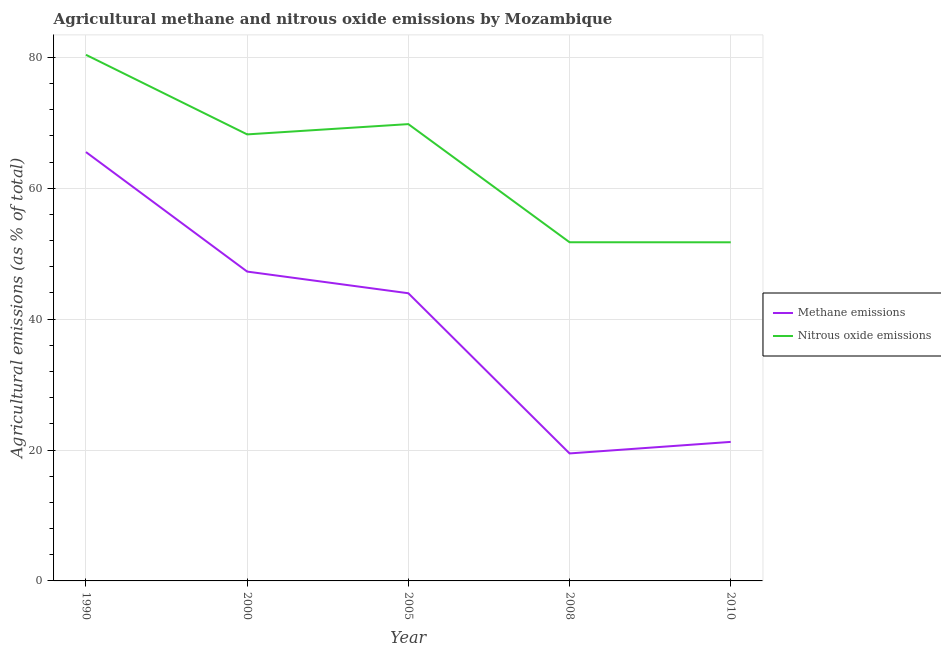How many different coloured lines are there?
Keep it short and to the point. 2. Does the line corresponding to amount of methane emissions intersect with the line corresponding to amount of nitrous oxide emissions?
Offer a very short reply. No. Is the number of lines equal to the number of legend labels?
Your response must be concise. Yes. What is the amount of nitrous oxide emissions in 2008?
Give a very brief answer. 51.75. Across all years, what is the maximum amount of methane emissions?
Ensure brevity in your answer.  65.53. Across all years, what is the minimum amount of nitrous oxide emissions?
Keep it short and to the point. 51.74. What is the total amount of nitrous oxide emissions in the graph?
Your answer should be compact. 321.92. What is the difference between the amount of nitrous oxide emissions in 2008 and that in 2010?
Offer a terse response. 0.01. What is the difference between the amount of nitrous oxide emissions in 2005 and the amount of methane emissions in 1990?
Ensure brevity in your answer.  4.27. What is the average amount of nitrous oxide emissions per year?
Provide a succinct answer. 64.38. In the year 2008, what is the difference between the amount of methane emissions and amount of nitrous oxide emissions?
Offer a very short reply. -32.27. In how many years, is the amount of nitrous oxide emissions greater than 32 %?
Your response must be concise. 5. What is the ratio of the amount of methane emissions in 2008 to that in 2010?
Keep it short and to the point. 0.92. What is the difference between the highest and the second highest amount of methane emissions?
Provide a short and direct response. 18.26. What is the difference between the highest and the lowest amount of methane emissions?
Ensure brevity in your answer.  46.05. How many lines are there?
Your answer should be compact. 2. How many years are there in the graph?
Your answer should be very brief. 5. What is the difference between two consecutive major ticks on the Y-axis?
Offer a very short reply. 20. How many legend labels are there?
Your answer should be very brief. 2. How are the legend labels stacked?
Provide a short and direct response. Vertical. What is the title of the graph?
Offer a terse response. Agricultural methane and nitrous oxide emissions by Mozambique. Does "Urban Population" appear as one of the legend labels in the graph?
Offer a very short reply. No. What is the label or title of the X-axis?
Offer a very short reply. Year. What is the label or title of the Y-axis?
Your response must be concise. Agricultural emissions (as % of total). What is the Agricultural emissions (as % of total) in Methane emissions in 1990?
Your answer should be compact. 65.53. What is the Agricultural emissions (as % of total) in Nitrous oxide emissions in 1990?
Your answer should be compact. 80.39. What is the Agricultural emissions (as % of total) in Methane emissions in 2000?
Your answer should be compact. 47.27. What is the Agricultural emissions (as % of total) in Nitrous oxide emissions in 2000?
Your answer should be compact. 68.23. What is the Agricultural emissions (as % of total) in Methane emissions in 2005?
Your answer should be compact. 43.96. What is the Agricultural emissions (as % of total) of Nitrous oxide emissions in 2005?
Keep it short and to the point. 69.8. What is the Agricultural emissions (as % of total) in Methane emissions in 2008?
Provide a succinct answer. 19.48. What is the Agricultural emissions (as % of total) of Nitrous oxide emissions in 2008?
Provide a short and direct response. 51.75. What is the Agricultural emissions (as % of total) in Methane emissions in 2010?
Offer a terse response. 21.24. What is the Agricultural emissions (as % of total) of Nitrous oxide emissions in 2010?
Offer a very short reply. 51.74. Across all years, what is the maximum Agricultural emissions (as % of total) in Methane emissions?
Offer a terse response. 65.53. Across all years, what is the maximum Agricultural emissions (as % of total) in Nitrous oxide emissions?
Your answer should be very brief. 80.39. Across all years, what is the minimum Agricultural emissions (as % of total) of Methane emissions?
Make the answer very short. 19.48. Across all years, what is the minimum Agricultural emissions (as % of total) in Nitrous oxide emissions?
Make the answer very short. 51.74. What is the total Agricultural emissions (as % of total) of Methane emissions in the graph?
Provide a succinct answer. 197.48. What is the total Agricultural emissions (as % of total) in Nitrous oxide emissions in the graph?
Offer a terse response. 321.92. What is the difference between the Agricultural emissions (as % of total) in Methane emissions in 1990 and that in 2000?
Offer a very short reply. 18.26. What is the difference between the Agricultural emissions (as % of total) in Nitrous oxide emissions in 1990 and that in 2000?
Your response must be concise. 12.16. What is the difference between the Agricultural emissions (as % of total) of Methane emissions in 1990 and that in 2005?
Your answer should be compact. 21.57. What is the difference between the Agricultural emissions (as % of total) in Nitrous oxide emissions in 1990 and that in 2005?
Your answer should be very brief. 10.59. What is the difference between the Agricultural emissions (as % of total) in Methane emissions in 1990 and that in 2008?
Your answer should be very brief. 46.05. What is the difference between the Agricultural emissions (as % of total) in Nitrous oxide emissions in 1990 and that in 2008?
Provide a succinct answer. 28.64. What is the difference between the Agricultural emissions (as % of total) in Methane emissions in 1990 and that in 2010?
Your answer should be very brief. 44.29. What is the difference between the Agricultural emissions (as % of total) of Nitrous oxide emissions in 1990 and that in 2010?
Your response must be concise. 28.65. What is the difference between the Agricultural emissions (as % of total) of Methane emissions in 2000 and that in 2005?
Offer a terse response. 3.31. What is the difference between the Agricultural emissions (as % of total) in Nitrous oxide emissions in 2000 and that in 2005?
Offer a very short reply. -1.57. What is the difference between the Agricultural emissions (as % of total) of Methane emissions in 2000 and that in 2008?
Give a very brief answer. 27.79. What is the difference between the Agricultural emissions (as % of total) in Nitrous oxide emissions in 2000 and that in 2008?
Make the answer very short. 16.48. What is the difference between the Agricultural emissions (as % of total) in Methane emissions in 2000 and that in 2010?
Ensure brevity in your answer.  26.02. What is the difference between the Agricultural emissions (as % of total) in Nitrous oxide emissions in 2000 and that in 2010?
Offer a terse response. 16.49. What is the difference between the Agricultural emissions (as % of total) of Methane emissions in 2005 and that in 2008?
Offer a very short reply. 24.48. What is the difference between the Agricultural emissions (as % of total) of Nitrous oxide emissions in 2005 and that in 2008?
Your response must be concise. 18.05. What is the difference between the Agricultural emissions (as % of total) of Methane emissions in 2005 and that in 2010?
Your response must be concise. 22.71. What is the difference between the Agricultural emissions (as % of total) in Nitrous oxide emissions in 2005 and that in 2010?
Provide a succinct answer. 18.06. What is the difference between the Agricultural emissions (as % of total) of Methane emissions in 2008 and that in 2010?
Provide a succinct answer. -1.76. What is the difference between the Agricultural emissions (as % of total) of Nitrous oxide emissions in 2008 and that in 2010?
Keep it short and to the point. 0.01. What is the difference between the Agricultural emissions (as % of total) of Methane emissions in 1990 and the Agricultural emissions (as % of total) of Nitrous oxide emissions in 2000?
Keep it short and to the point. -2.7. What is the difference between the Agricultural emissions (as % of total) of Methane emissions in 1990 and the Agricultural emissions (as % of total) of Nitrous oxide emissions in 2005?
Ensure brevity in your answer.  -4.27. What is the difference between the Agricultural emissions (as % of total) in Methane emissions in 1990 and the Agricultural emissions (as % of total) in Nitrous oxide emissions in 2008?
Offer a terse response. 13.78. What is the difference between the Agricultural emissions (as % of total) in Methane emissions in 1990 and the Agricultural emissions (as % of total) in Nitrous oxide emissions in 2010?
Offer a terse response. 13.79. What is the difference between the Agricultural emissions (as % of total) of Methane emissions in 2000 and the Agricultural emissions (as % of total) of Nitrous oxide emissions in 2005?
Keep it short and to the point. -22.53. What is the difference between the Agricultural emissions (as % of total) in Methane emissions in 2000 and the Agricultural emissions (as % of total) in Nitrous oxide emissions in 2008?
Offer a very short reply. -4.48. What is the difference between the Agricultural emissions (as % of total) in Methane emissions in 2000 and the Agricultural emissions (as % of total) in Nitrous oxide emissions in 2010?
Keep it short and to the point. -4.47. What is the difference between the Agricultural emissions (as % of total) of Methane emissions in 2005 and the Agricultural emissions (as % of total) of Nitrous oxide emissions in 2008?
Keep it short and to the point. -7.79. What is the difference between the Agricultural emissions (as % of total) in Methane emissions in 2005 and the Agricultural emissions (as % of total) in Nitrous oxide emissions in 2010?
Ensure brevity in your answer.  -7.79. What is the difference between the Agricultural emissions (as % of total) in Methane emissions in 2008 and the Agricultural emissions (as % of total) in Nitrous oxide emissions in 2010?
Your answer should be compact. -32.26. What is the average Agricultural emissions (as % of total) of Methane emissions per year?
Make the answer very short. 39.5. What is the average Agricultural emissions (as % of total) of Nitrous oxide emissions per year?
Your answer should be very brief. 64.38. In the year 1990, what is the difference between the Agricultural emissions (as % of total) in Methane emissions and Agricultural emissions (as % of total) in Nitrous oxide emissions?
Ensure brevity in your answer.  -14.86. In the year 2000, what is the difference between the Agricultural emissions (as % of total) in Methane emissions and Agricultural emissions (as % of total) in Nitrous oxide emissions?
Offer a terse response. -20.96. In the year 2005, what is the difference between the Agricultural emissions (as % of total) of Methane emissions and Agricultural emissions (as % of total) of Nitrous oxide emissions?
Ensure brevity in your answer.  -25.84. In the year 2008, what is the difference between the Agricultural emissions (as % of total) in Methane emissions and Agricultural emissions (as % of total) in Nitrous oxide emissions?
Your answer should be compact. -32.27. In the year 2010, what is the difference between the Agricultural emissions (as % of total) of Methane emissions and Agricultural emissions (as % of total) of Nitrous oxide emissions?
Offer a terse response. -30.5. What is the ratio of the Agricultural emissions (as % of total) in Methane emissions in 1990 to that in 2000?
Provide a succinct answer. 1.39. What is the ratio of the Agricultural emissions (as % of total) in Nitrous oxide emissions in 1990 to that in 2000?
Your answer should be compact. 1.18. What is the ratio of the Agricultural emissions (as % of total) in Methane emissions in 1990 to that in 2005?
Your answer should be very brief. 1.49. What is the ratio of the Agricultural emissions (as % of total) in Nitrous oxide emissions in 1990 to that in 2005?
Make the answer very short. 1.15. What is the ratio of the Agricultural emissions (as % of total) in Methane emissions in 1990 to that in 2008?
Your answer should be compact. 3.36. What is the ratio of the Agricultural emissions (as % of total) of Nitrous oxide emissions in 1990 to that in 2008?
Your answer should be compact. 1.55. What is the ratio of the Agricultural emissions (as % of total) in Methane emissions in 1990 to that in 2010?
Provide a succinct answer. 3.08. What is the ratio of the Agricultural emissions (as % of total) in Nitrous oxide emissions in 1990 to that in 2010?
Offer a terse response. 1.55. What is the ratio of the Agricultural emissions (as % of total) of Methane emissions in 2000 to that in 2005?
Give a very brief answer. 1.08. What is the ratio of the Agricultural emissions (as % of total) of Nitrous oxide emissions in 2000 to that in 2005?
Make the answer very short. 0.98. What is the ratio of the Agricultural emissions (as % of total) in Methane emissions in 2000 to that in 2008?
Make the answer very short. 2.43. What is the ratio of the Agricultural emissions (as % of total) of Nitrous oxide emissions in 2000 to that in 2008?
Your answer should be compact. 1.32. What is the ratio of the Agricultural emissions (as % of total) of Methane emissions in 2000 to that in 2010?
Provide a succinct answer. 2.23. What is the ratio of the Agricultural emissions (as % of total) of Nitrous oxide emissions in 2000 to that in 2010?
Make the answer very short. 1.32. What is the ratio of the Agricultural emissions (as % of total) of Methane emissions in 2005 to that in 2008?
Your answer should be very brief. 2.26. What is the ratio of the Agricultural emissions (as % of total) of Nitrous oxide emissions in 2005 to that in 2008?
Offer a very short reply. 1.35. What is the ratio of the Agricultural emissions (as % of total) in Methane emissions in 2005 to that in 2010?
Your answer should be compact. 2.07. What is the ratio of the Agricultural emissions (as % of total) in Nitrous oxide emissions in 2005 to that in 2010?
Provide a short and direct response. 1.35. What is the ratio of the Agricultural emissions (as % of total) of Methane emissions in 2008 to that in 2010?
Provide a succinct answer. 0.92. What is the difference between the highest and the second highest Agricultural emissions (as % of total) in Methane emissions?
Keep it short and to the point. 18.26. What is the difference between the highest and the second highest Agricultural emissions (as % of total) in Nitrous oxide emissions?
Provide a short and direct response. 10.59. What is the difference between the highest and the lowest Agricultural emissions (as % of total) of Methane emissions?
Provide a succinct answer. 46.05. What is the difference between the highest and the lowest Agricultural emissions (as % of total) of Nitrous oxide emissions?
Your response must be concise. 28.65. 